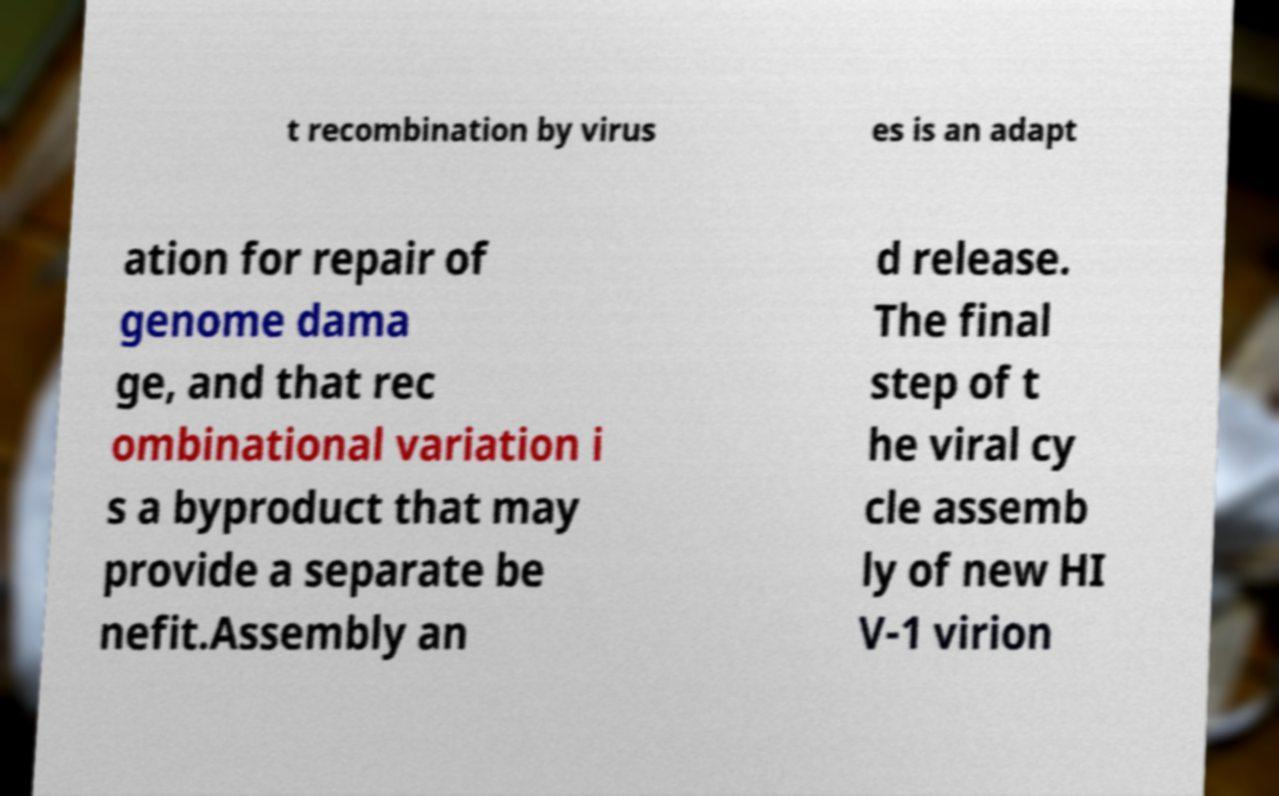There's text embedded in this image that I need extracted. Can you transcribe it verbatim? t recombination by virus es is an adapt ation for repair of genome dama ge, and that rec ombinational variation i s a byproduct that may provide a separate be nefit.Assembly an d release. The final step of t he viral cy cle assemb ly of new HI V-1 virion 